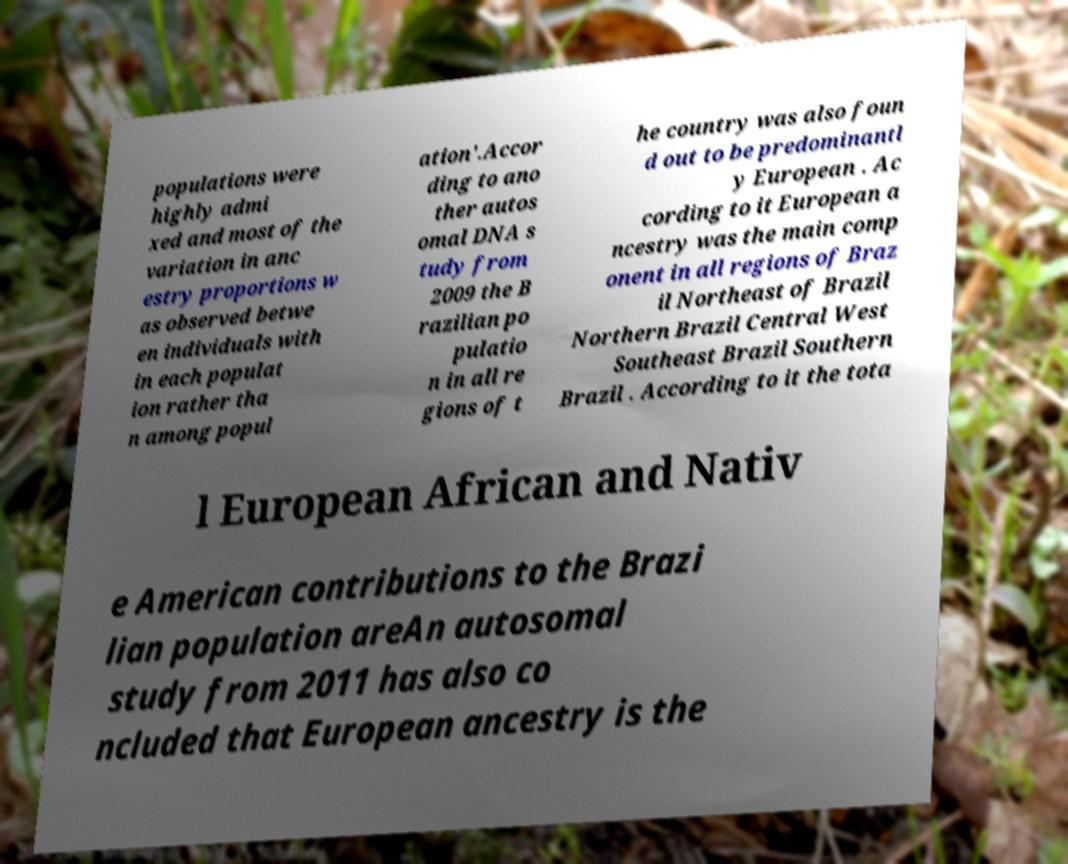For documentation purposes, I need the text within this image transcribed. Could you provide that? populations were highly admi xed and most of the variation in anc estry proportions w as observed betwe en individuals with in each populat ion rather tha n among popul ation'.Accor ding to ano ther autos omal DNA s tudy from 2009 the B razilian po pulatio n in all re gions of t he country was also foun d out to be predominantl y European . Ac cording to it European a ncestry was the main comp onent in all regions of Braz il Northeast of Brazil Northern Brazil Central West Southeast Brazil Southern Brazil . According to it the tota l European African and Nativ e American contributions to the Brazi lian population areAn autosomal study from 2011 has also co ncluded that European ancestry is the 